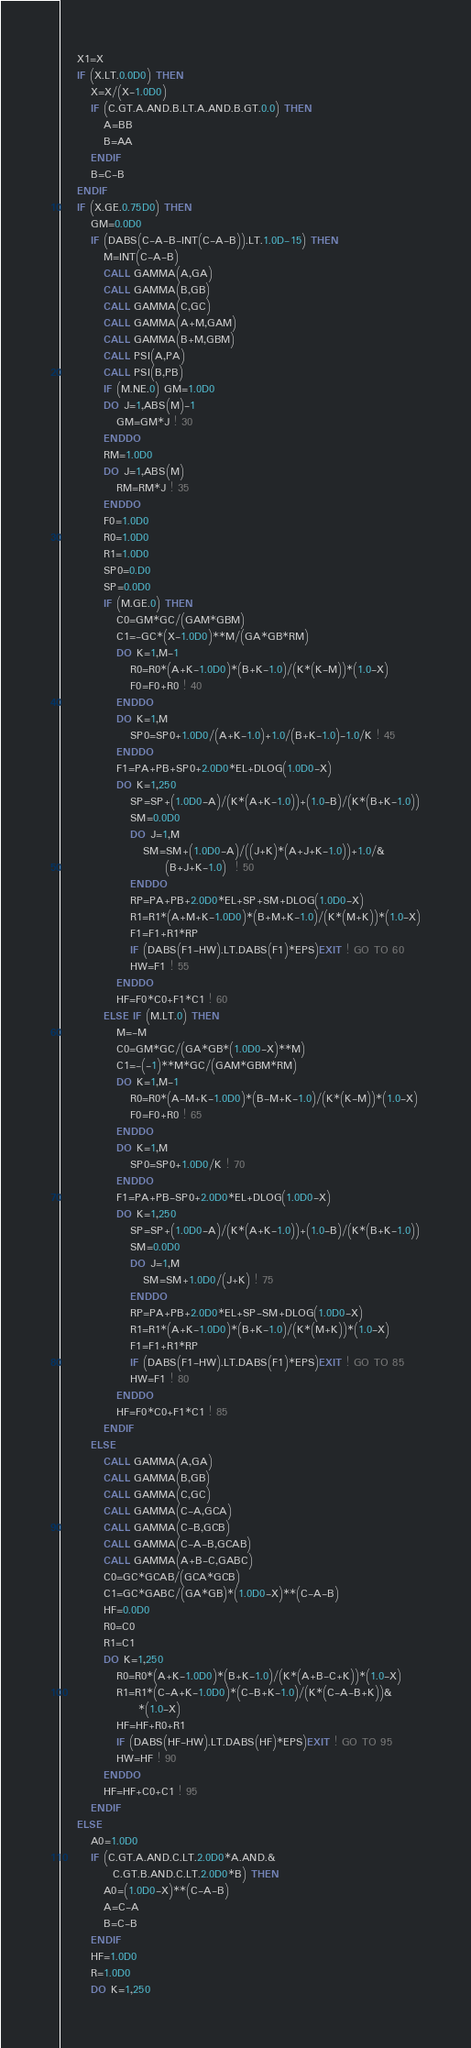<code> <loc_0><loc_0><loc_500><loc_500><_FORTRAN_>    X1=X
    IF (X.LT.0.0D0) THEN
       X=X/(X-1.0D0)
       IF (C.GT.A.AND.B.LT.A.AND.B.GT.0.0) THEN
          A=BB
          B=AA
       ENDIF
       B=C-B
    ENDIF
    IF (X.GE.0.75D0) THEN
       GM=0.0D0
       IF (DABS(C-A-B-INT(C-A-B)).LT.1.0D-15) THEN
          M=INT(C-A-B)
          CALL GAMMA(A,GA)
          CALL GAMMA(B,GB)
          CALL GAMMA(C,GC)
          CALL GAMMA(A+M,GAM)
          CALL GAMMA(B+M,GBM)
          CALL PSI(A,PA)
          CALL PSI(B,PB)
          IF (M.NE.0) GM=1.0D0
          DO J=1,ABS(M)-1
             GM=GM*J ! 30
          ENDDO
          RM=1.0D0
          DO J=1,ABS(M)
             RM=RM*J ! 35
          ENDDO
          F0=1.0D0
          R0=1.0D0
          R1=1.0D0
          SP0=0.D0
          SP=0.0D0
          IF (M.GE.0) THEN
             C0=GM*GC/(GAM*GBM)
             C1=-GC*(X-1.0D0)**M/(GA*GB*RM)
             DO K=1,M-1
                R0=R0*(A+K-1.0D0)*(B+K-1.0)/(K*(K-M))*(1.0-X)
                F0=F0+R0 ! 40
             ENDDO
             DO K=1,M
                SP0=SP0+1.0D0/(A+K-1.0)+1.0/(B+K-1.0)-1.0/K ! 45
             ENDDO
             F1=PA+PB+SP0+2.0D0*EL+DLOG(1.0D0-X)
             DO K=1,250
                SP=SP+(1.0D0-A)/(K*(A+K-1.0))+(1.0-B)/(K*(B+K-1.0))
                SM=0.0D0
                DO J=1,M
                   SM=SM+(1.0D0-A)/((J+K)*(A+J+K-1.0))+1.0/&
                        (B+J+K-1.0)  ! 50
                ENDDO
                RP=PA+PB+2.0D0*EL+SP+SM+DLOG(1.0D0-X)
                R1=R1*(A+M+K-1.0D0)*(B+M+K-1.0)/(K*(M+K))*(1.0-X)
                F1=F1+R1*RP
                IF (DABS(F1-HW).LT.DABS(F1)*EPS)EXIT ! GO TO 60
                HW=F1 ! 55
             ENDDO
             HF=F0*C0+F1*C1 ! 60
          ELSE IF (M.LT.0) THEN
             M=-M
             C0=GM*GC/(GA*GB*(1.0D0-X)**M)
             C1=-(-1)**M*GC/(GAM*GBM*RM)
             DO K=1,M-1
                R0=R0*(A-M+K-1.0D0)*(B-M+K-1.0)/(K*(K-M))*(1.0-X)
                F0=F0+R0 ! 65
             ENDDO
             DO K=1,M
                SP0=SP0+1.0D0/K ! 70
             ENDDO
             F1=PA+PB-SP0+2.0D0*EL+DLOG(1.0D0-X)
             DO K=1,250
                SP=SP+(1.0D0-A)/(K*(A+K-1.0))+(1.0-B)/(K*(B+K-1.0))
                SM=0.0D0
                DO J=1,M
                   SM=SM+1.0D0/(J+K) ! 75
                ENDDO
                RP=PA+PB+2.0D0*EL+SP-SM+DLOG(1.0D0-X)
                R1=R1*(A+K-1.0D0)*(B+K-1.0)/(K*(M+K))*(1.0-X)
                F1=F1+R1*RP
                IF (DABS(F1-HW).LT.DABS(F1)*EPS)EXIT ! GO TO 85
                HW=F1 ! 80
             ENDDO
             HF=F0*C0+F1*C1 ! 85
          ENDIF
       ELSE
          CALL GAMMA(A,GA)
          CALL GAMMA(B,GB)
          CALL GAMMA(C,GC)
          CALL GAMMA(C-A,GCA)
          CALL GAMMA(C-B,GCB)
          CALL GAMMA(C-A-B,GCAB)
          CALL GAMMA(A+B-C,GABC)
          C0=GC*GCAB/(GCA*GCB)
          C1=GC*GABC/(GA*GB)*(1.0D0-X)**(C-A-B)
          HF=0.0D0
          R0=C0
          R1=C1
          DO K=1,250
             R0=R0*(A+K-1.0D0)*(B+K-1.0)/(K*(A+B-C+K))*(1.0-X)
             R1=R1*(C-A+K-1.0D0)*(C-B+K-1.0)/(K*(C-A-B+K))&
                  *(1.0-X)
             HF=HF+R0+R1
             IF (DABS(HF-HW).LT.DABS(HF)*EPS)EXIT ! GO TO 95
             HW=HF ! 90
          ENDDO
          HF=HF+C0+C1 ! 95
       ENDIF
    ELSE
       A0=1.0D0
       IF (C.GT.A.AND.C.LT.2.0D0*A.AND.&
            C.GT.B.AND.C.LT.2.0D0*B) THEN
          A0=(1.0D0-X)**(C-A-B)
          A=C-A
          B=C-B
       ENDIF
       HF=1.0D0
       R=1.0D0
       DO K=1,250</code> 